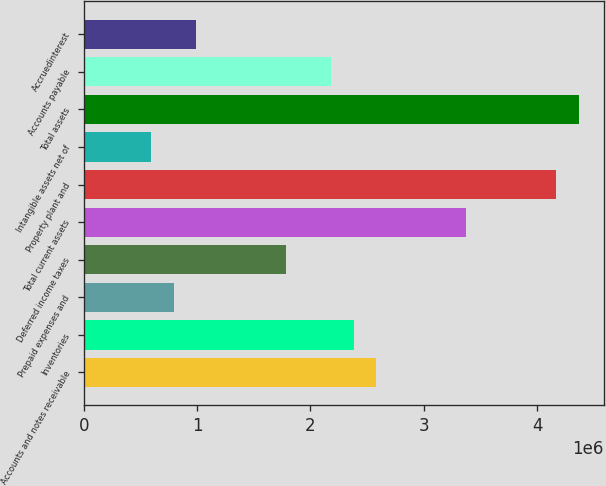<chart> <loc_0><loc_0><loc_500><loc_500><bar_chart><fcel>Accounts and notes receivable<fcel>Inventories<fcel>Prepaid expenses and<fcel>Deferred income taxes<fcel>Total current assets<fcel>Property plant and<fcel>Intangible assets net of<fcel>Total assets<fcel>Accounts payable<fcel>Accruedinterest<nl><fcel>2.58066e+06<fcel>2.38215e+06<fcel>794064<fcel>1.78662e+06<fcel>3.3747e+06<fcel>4.16874e+06<fcel>595554<fcel>4.36725e+06<fcel>2.18364e+06<fcel>992574<nl></chart> 